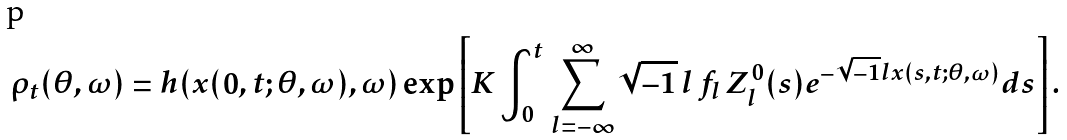Convert formula to latex. <formula><loc_0><loc_0><loc_500><loc_500>\rho _ { t } ( \theta , \omega ) = h ( x ( 0 , t ; \theta , \omega ) , \omega ) \exp \left [ K \int ^ { t } _ { 0 } \, \sum ^ { \infty } _ { l = - \infty } \sqrt { - 1 } \, l \, f _ { l } \, Z ^ { 0 } _ { l } ( s ) e ^ { - \sqrt { - 1 } l x ( s , t ; \theta , \omega ) } d s \right ] .</formula> 